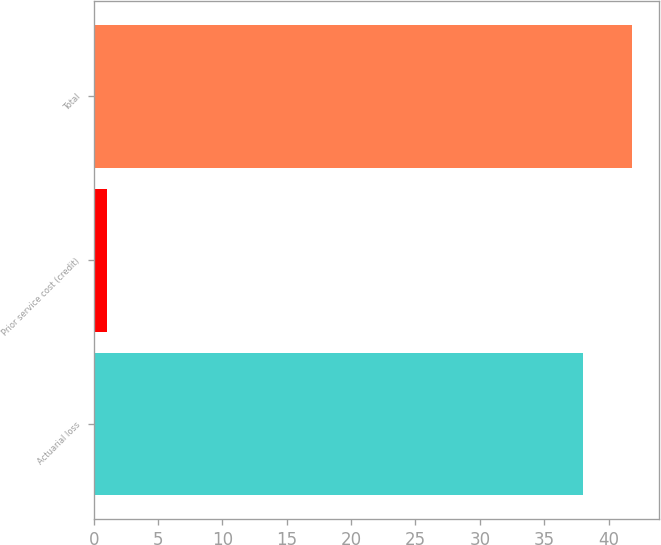<chart> <loc_0><loc_0><loc_500><loc_500><bar_chart><fcel>Actuarial loss<fcel>Prior service cost (credit)<fcel>Total<nl><fcel>38<fcel>1<fcel>41.8<nl></chart> 